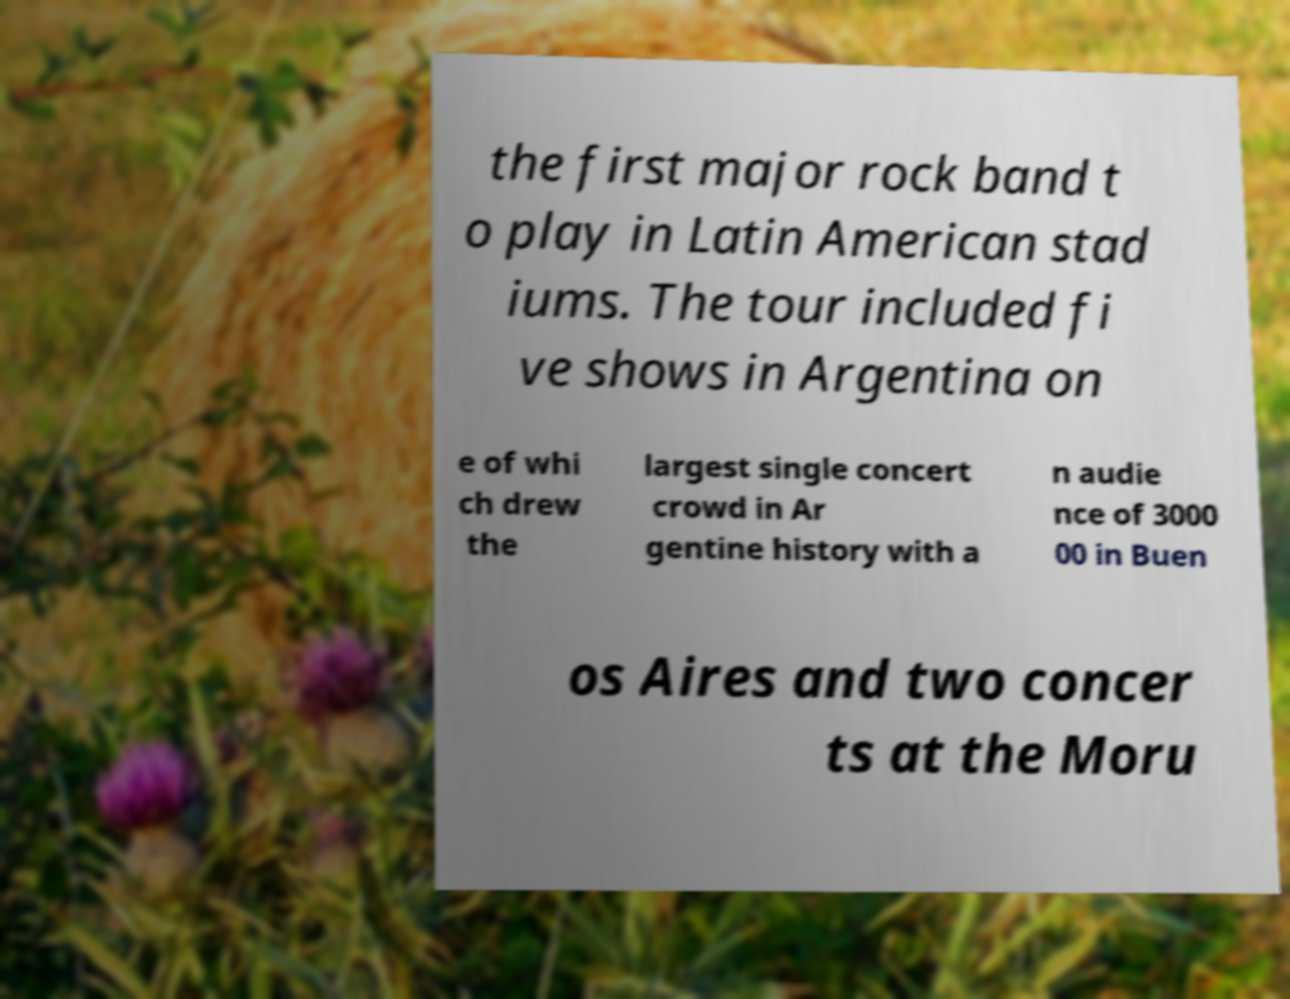For documentation purposes, I need the text within this image transcribed. Could you provide that? the first major rock band t o play in Latin American stad iums. The tour included fi ve shows in Argentina on e of whi ch drew the largest single concert crowd in Ar gentine history with a n audie nce of 3000 00 in Buen os Aires and two concer ts at the Moru 